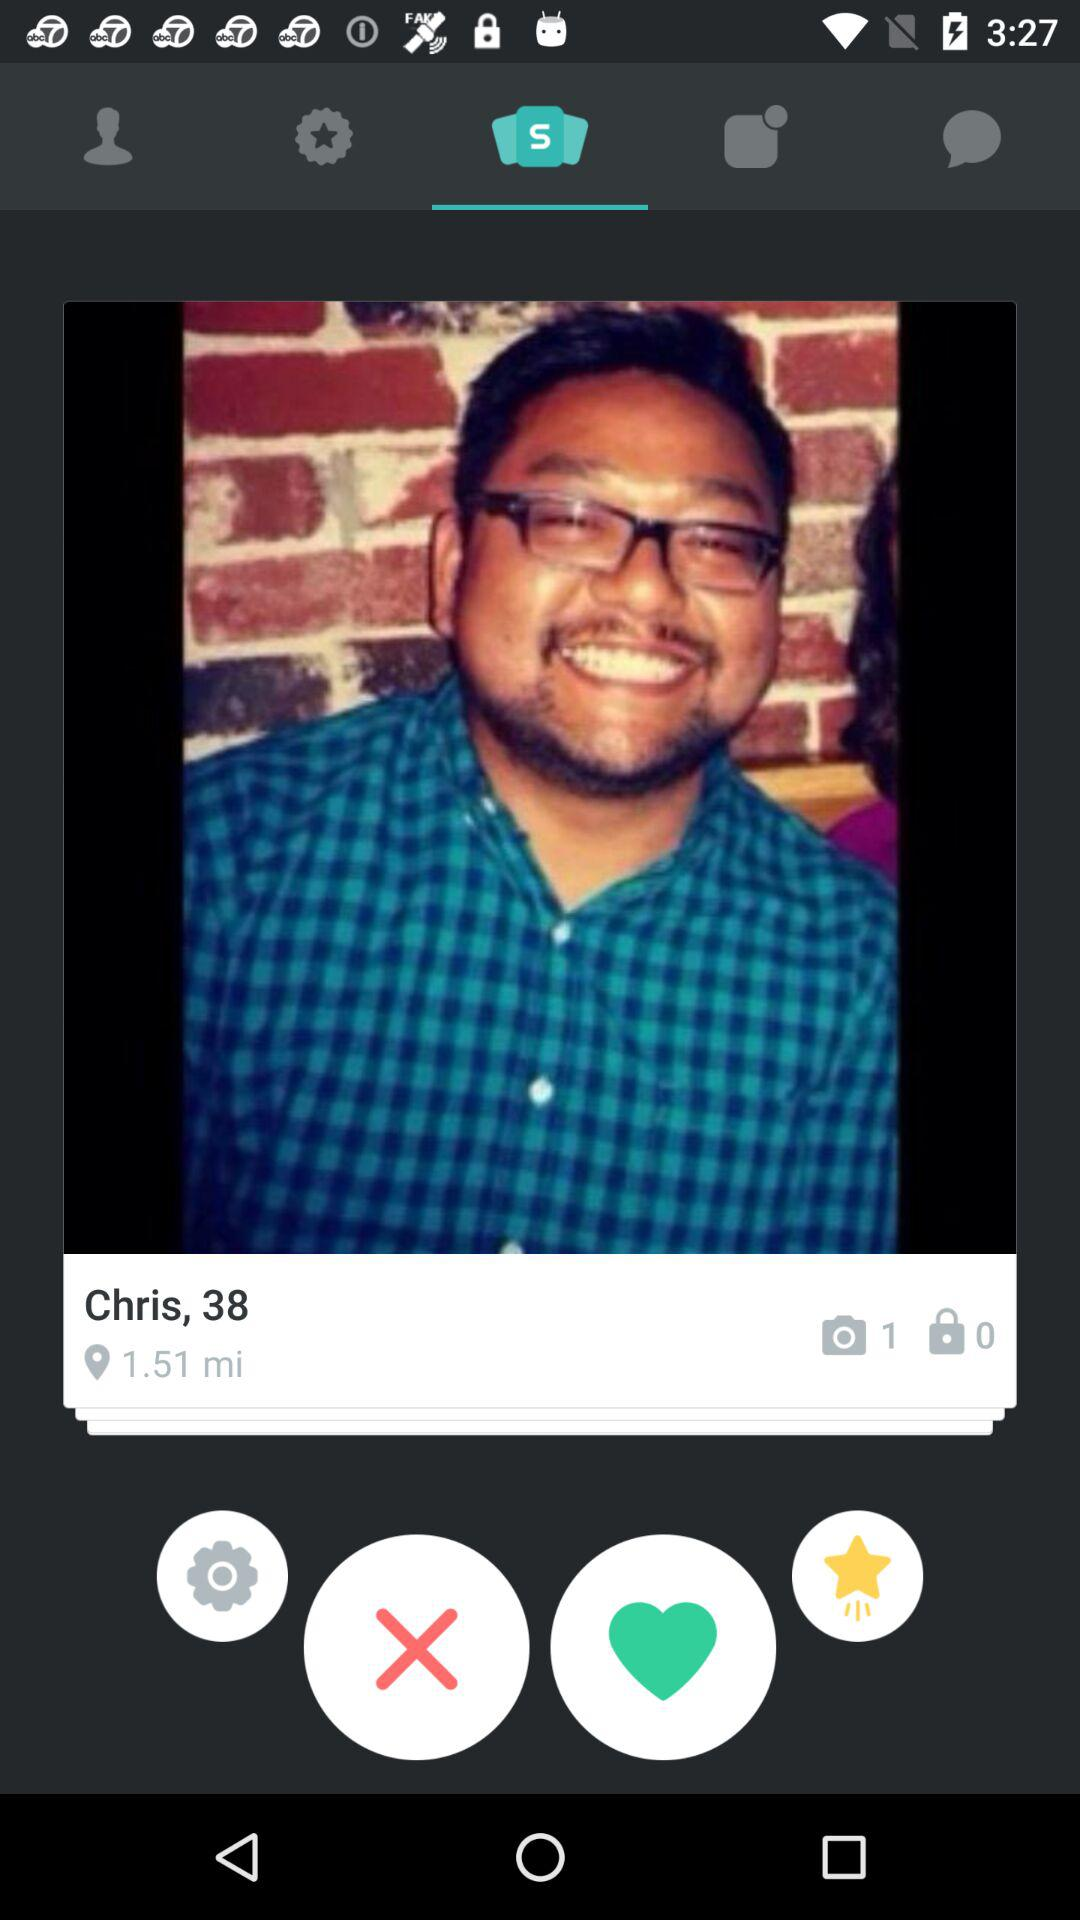How many photos in camera? There is 1 photo in the camera. 